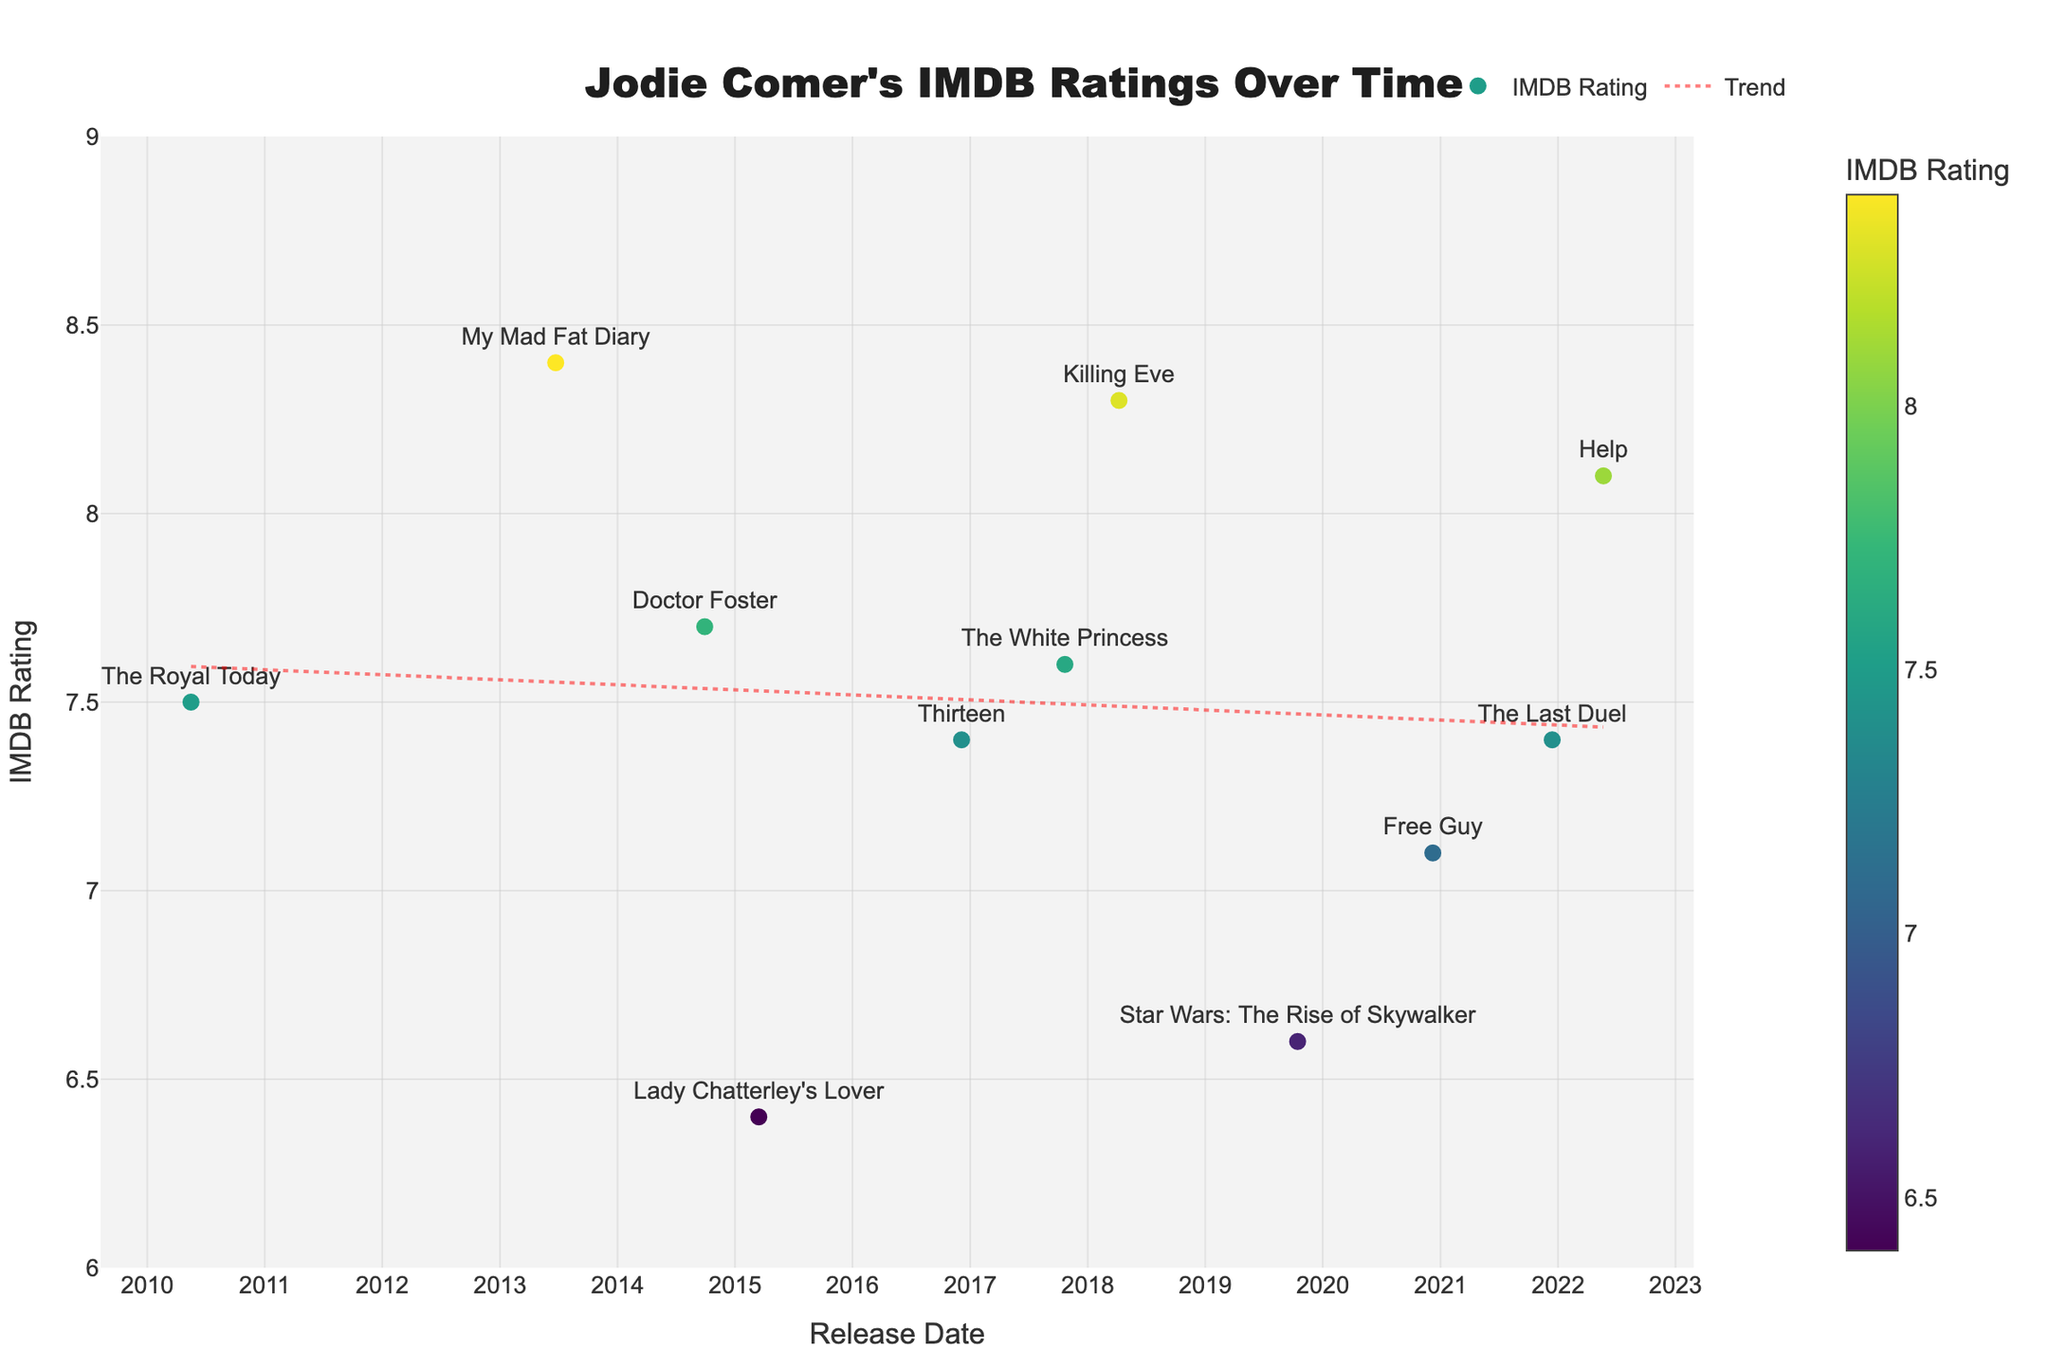What is the title of the plot? The title is prominently displayed at the top of the plot.
Answer: Jodie Comer's IMDB Ratings Over Time How many TV shows and movies are shown in the plot? Each TV show or movie is represented by a separate marker on the scatter plot. Count the number of markers.
Answer: 11 What is the highest IMDB rating displayed on the plot, and for which show or movie? Look for the marker with the highest position on the y-axis and check its associated label.
Answer: 8.4, My Mad Fat Diary What is the trend of Jodie Comer's IMDB ratings over time? The red dotted line represents the trend. Observe its slope to determine if it is increasing, decreasing, or remaining constant.
Answer: Increasing Which TV show or movie has the lowest IMDB rating, and what is that rating? Identify the marker at the lowest vertical position on the y-axis and read its label.
Answer: Lady Chatterley's Lover, 6.4 How does the IMDB rating of "Killing Eve" compare to that of "Doctor Foster"? Find the markers for both "Killing Eve" and "Doctor Foster" and compare their y-axis positions.
Answer: Killing Eve is higher What is the average IMDB rating of all the TV shows and movies? Sum all the IMDB ratings and divide by the number of data points (11).
Answer: 7.55 How many shows or movies have an IMDB rating higher than 8? Count the number of markers above the y-axis value of 8.
Answer: 3 Which TV show or movie is represented by the marker closest to May 2022? Examine the x-axis and identify which marker is nearest to May 2022.
Answer: Help Which project had an IMDB rating of 7.1, and when was it released? Look for the marker at the y-axis value of 7.1 and read its label and x-axis position.
Answer: Free Guy, December 2020 